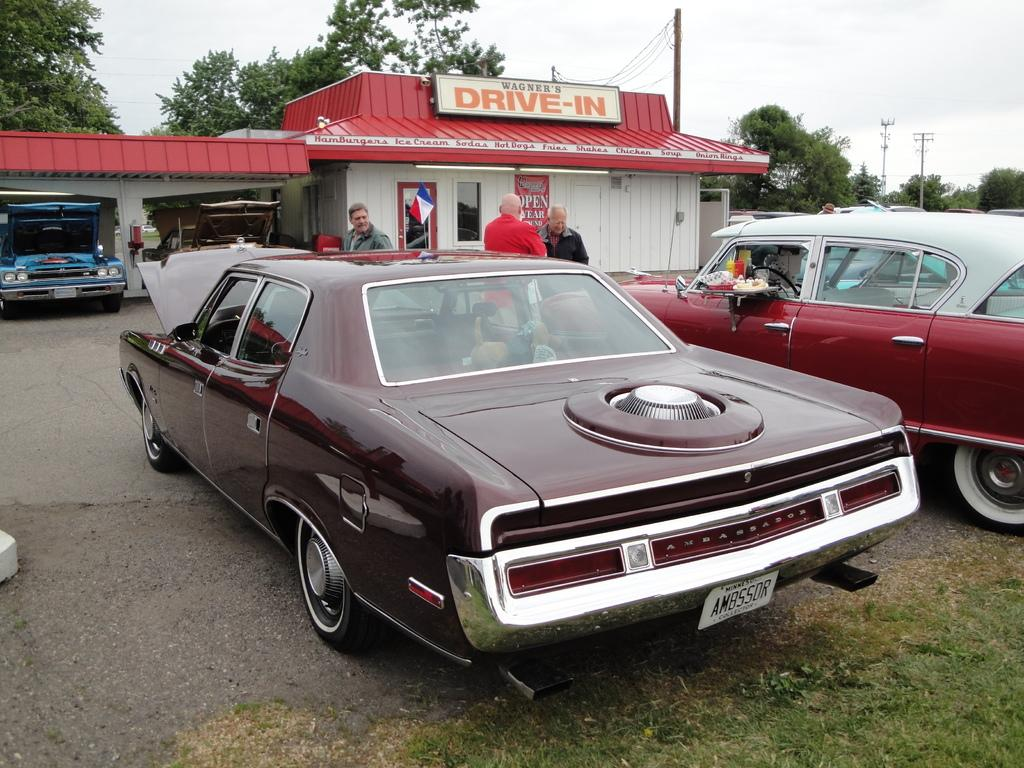What can be seen on the pavement in the image? There are vehicles on a pavement in the image. What else is present in the image besides the vehicles? There are people standing near the vehicles. What is visible in the background of the image? There is a garage, a tree, poles, and the sky visible in the background of the image. What type of apparel is being ironed in the image? There is no apparel or iron present in the image. What letters are visible on the vehicles in the image? The provided facts do not mention any letters on the vehicles, so we cannot answer this question definitively. 